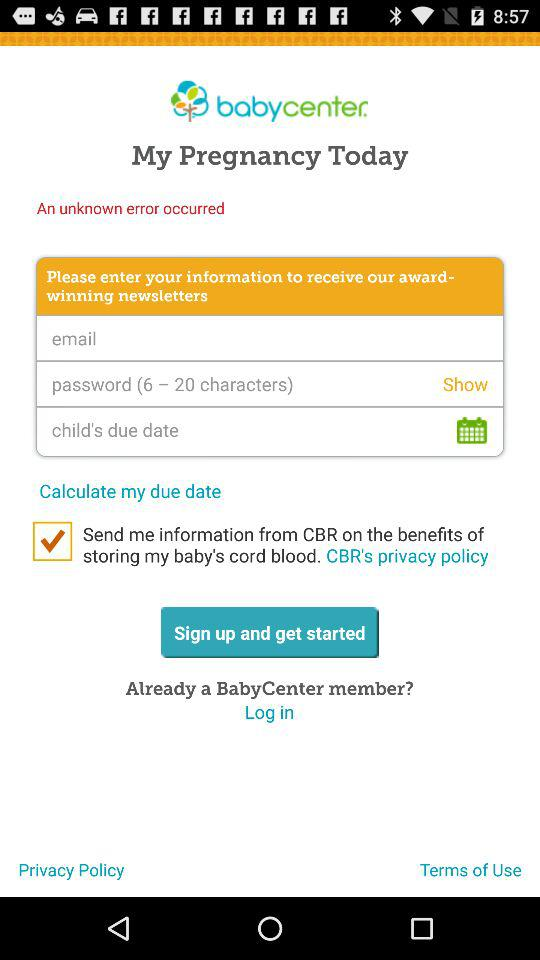What is the number of characters required for a password? The number of characters required for a password is 6 to 20. 